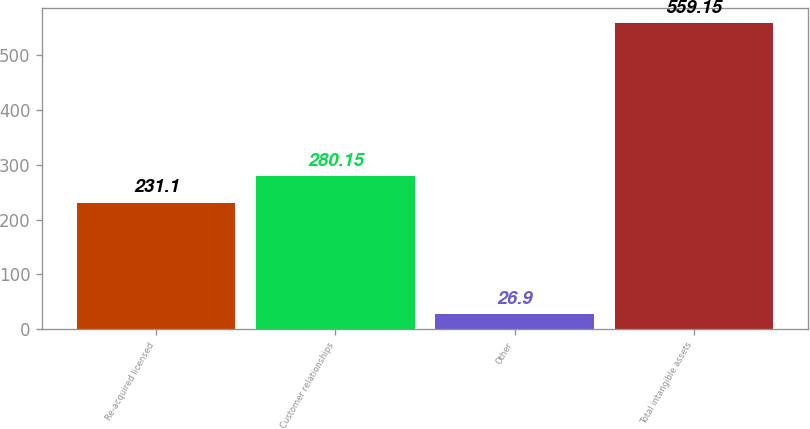<chart> <loc_0><loc_0><loc_500><loc_500><bar_chart><fcel>Re-acquired licensed<fcel>Customer relationships<fcel>Other<fcel>Total intangible assets<nl><fcel>231.1<fcel>280.15<fcel>26.9<fcel>559.15<nl></chart> 